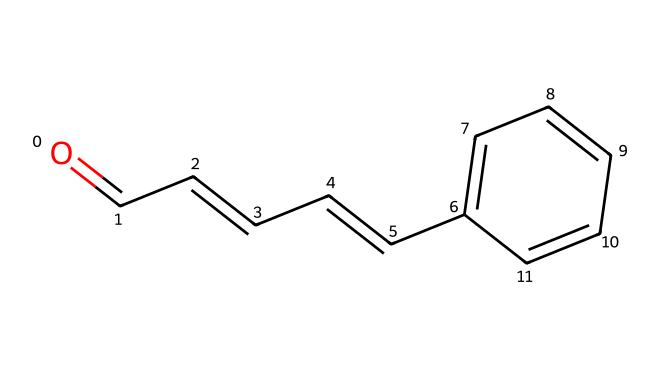what is the common name of this compound? The structure corresponds to cinnamaldehyde, which is the common name for this organic compound widely recognized for its contribution to cinnamon's aroma and flavor.
Answer: cinnamaldehyde how many carbon atoms are in the structure? By counting the carbon atoms (C) in the SMILES representation, we find a total of 9 carbon atoms present in the molecule.
Answer: 9 how many double bonds are visible in the structure? The SMILES notation indicates several double bonds between the carbon atoms. There are 4 double bonds present in the structure.
Answer: 4 what functional group is present in this compound? The SMILES notation reveals an aldehyde group (characterized by the carbonyl functional group) among the carbon chain. This indicates the presence of the aldehyde functional group in the structure.
Answer: aldehyde what is the molecular formula of cinnamaldehyde? From the structure, we can derive the molecular formula by counting the number of each type of atom: 9 carbons (C), 8 hydrogens (H), and 1 oxygen (O), resulting in the formula C9H8O.
Answer: C9H8O how does the structure of cinnamaldehyde relate to its aroma? The structure features a phenyl ring and an aldehyde group, which together contribute to the characteristic aromatic profile and sensory impact associated with cinnamon flavors.
Answer: phenyl ring and aldehyde group 